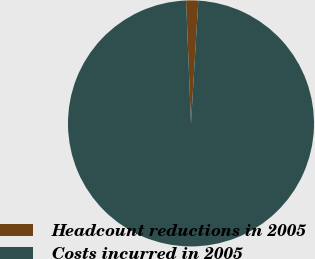Convert chart to OTSL. <chart><loc_0><loc_0><loc_500><loc_500><pie_chart><fcel>Headcount reductions in 2005<fcel>Costs incurred in 2005<nl><fcel>1.58%<fcel>98.42%<nl></chart> 